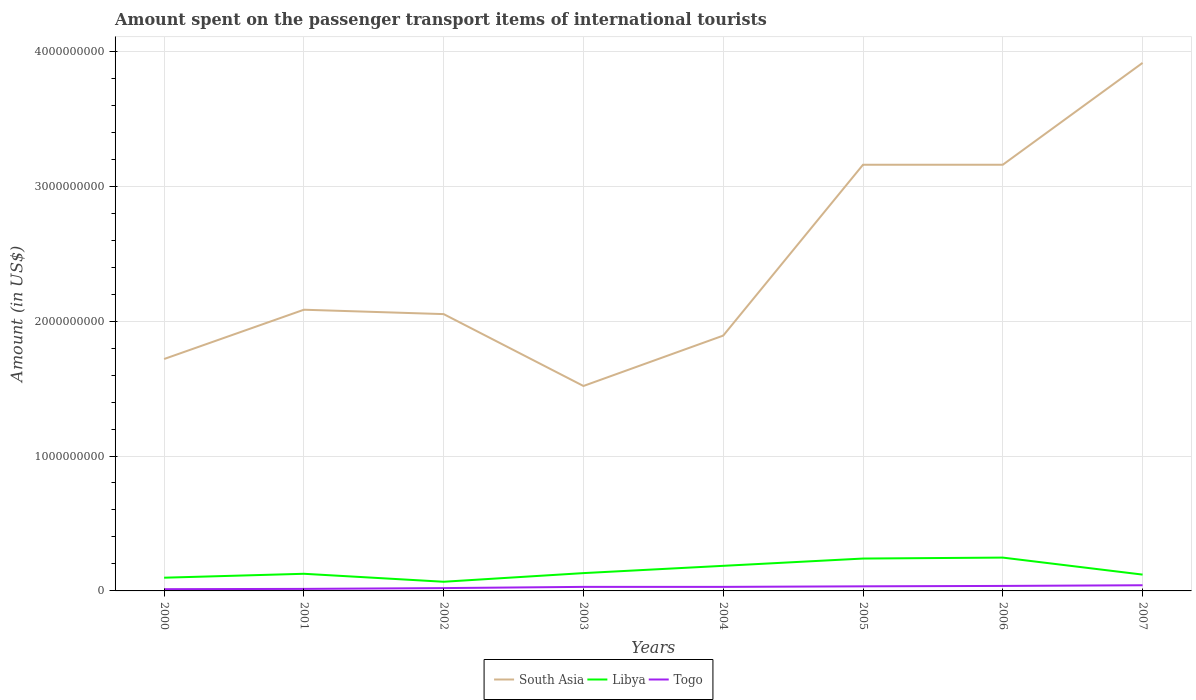Across all years, what is the maximum amount spent on the passenger transport items of international tourists in Togo?
Your response must be concise. 1.30e+07. In which year was the amount spent on the passenger transport items of international tourists in Togo maximum?
Offer a terse response. 2000. What is the total amount spent on the passenger transport items of international tourists in South Asia in the graph?
Make the answer very short. -1.07e+09. What is the difference between the highest and the second highest amount spent on the passenger transport items of international tourists in Togo?
Provide a short and direct response. 2.90e+07. Is the amount spent on the passenger transport items of international tourists in South Asia strictly greater than the amount spent on the passenger transport items of international tourists in Libya over the years?
Offer a very short reply. No. Are the values on the major ticks of Y-axis written in scientific E-notation?
Your answer should be very brief. No. Does the graph contain any zero values?
Keep it short and to the point. No. Where does the legend appear in the graph?
Your answer should be compact. Bottom center. What is the title of the graph?
Keep it short and to the point. Amount spent on the passenger transport items of international tourists. Does "Kenya" appear as one of the legend labels in the graph?
Make the answer very short. No. What is the Amount (in US$) in South Asia in 2000?
Your response must be concise. 1.72e+09. What is the Amount (in US$) of Libya in 2000?
Your answer should be very brief. 9.80e+07. What is the Amount (in US$) of Togo in 2000?
Provide a short and direct response. 1.30e+07. What is the Amount (in US$) of South Asia in 2001?
Offer a terse response. 2.08e+09. What is the Amount (in US$) of Libya in 2001?
Offer a very short reply. 1.27e+08. What is the Amount (in US$) in Togo in 2001?
Give a very brief answer. 1.50e+07. What is the Amount (in US$) of South Asia in 2002?
Your response must be concise. 2.05e+09. What is the Amount (in US$) in Libya in 2002?
Offer a very short reply. 6.80e+07. What is the Amount (in US$) in Togo in 2002?
Give a very brief answer. 2.10e+07. What is the Amount (in US$) of South Asia in 2003?
Your answer should be very brief. 1.52e+09. What is the Amount (in US$) of Libya in 2003?
Provide a succinct answer. 1.32e+08. What is the Amount (in US$) of Togo in 2003?
Provide a short and direct response. 3.00e+07. What is the Amount (in US$) of South Asia in 2004?
Make the answer very short. 1.89e+09. What is the Amount (in US$) in Libya in 2004?
Give a very brief answer. 1.86e+08. What is the Amount (in US$) of Togo in 2004?
Give a very brief answer. 3.00e+07. What is the Amount (in US$) in South Asia in 2005?
Offer a terse response. 3.16e+09. What is the Amount (in US$) in Libya in 2005?
Your response must be concise. 2.40e+08. What is the Amount (in US$) of Togo in 2005?
Make the answer very short. 3.40e+07. What is the Amount (in US$) in South Asia in 2006?
Your response must be concise. 3.16e+09. What is the Amount (in US$) of Libya in 2006?
Give a very brief answer. 2.47e+08. What is the Amount (in US$) in Togo in 2006?
Give a very brief answer. 3.70e+07. What is the Amount (in US$) of South Asia in 2007?
Give a very brief answer. 3.91e+09. What is the Amount (in US$) in Libya in 2007?
Keep it short and to the point. 1.21e+08. What is the Amount (in US$) of Togo in 2007?
Ensure brevity in your answer.  4.20e+07. Across all years, what is the maximum Amount (in US$) of South Asia?
Offer a terse response. 3.91e+09. Across all years, what is the maximum Amount (in US$) in Libya?
Offer a very short reply. 2.47e+08. Across all years, what is the maximum Amount (in US$) in Togo?
Your response must be concise. 4.20e+07. Across all years, what is the minimum Amount (in US$) of South Asia?
Your answer should be compact. 1.52e+09. Across all years, what is the minimum Amount (in US$) of Libya?
Ensure brevity in your answer.  6.80e+07. Across all years, what is the minimum Amount (in US$) of Togo?
Offer a terse response. 1.30e+07. What is the total Amount (in US$) of South Asia in the graph?
Ensure brevity in your answer.  1.95e+1. What is the total Amount (in US$) in Libya in the graph?
Provide a short and direct response. 1.22e+09. What is the total Amount (in US$) in Togo in the graph?
Keep it short and to the point. 2.22e+08. What is the difference between the Amount (in US$) of South Asia in 2000 and that in 2001?
Offer a terse response. -3.65e+08. What is the difference between the Amount (in US$) in Libya in 2000 and that in 2001?
Keep it short and to the point. -2.90e+07. What is the difference between the Amount (in US$) of South Asia in 2000 and that in 2002?
Give a very brief answer. -3.33e+08. What is the difference between the Amount (in US$) in Libya in 2000 and that in 2002?
Make the answer very short. 3.00e+07. What is the difference between the Amount (in US$) of Togo in 2000 and that in 2002?
Your response must be concise. -8.00e+06. What is the difference between the Amount (in US$) in South Asia in 2000 and that in 2003?
Provide a succinct answer. 2.00e+08. What is the difference between the Amount (in US$) of Libya in 2000 and that in 2003?
Offer a very short reply. -3.40e+07. What is the difference between the Amount (in US$) of Togo in 2000 and that in 2003?
Your answer should be compact. -1.70e+07. What is the difference between the Amount (in US$) of South Asia in 2000 and that in 2004?
Provide a succinct answer. -1.74e+08. What is the difference between the Amount (in US$) in Libya in 2000 and that in 2004?
Ensure brevity in your answer.  -8.80e+07. What is the difference between the Amount (in US$) in Togo in 2000 and that in 2004?
Keep it short and to the point. -1.70e+07. What is the difference between the Amount (in US$) of South Asia in 2000 and that in 2005?
Offer a terse response. -1.44e+09. What is the difference between the Amount (in US$) in Libya in 2000 and that in 2005?
Give a very brief answer. -1.42e+08. What is the difference between the Amount (in US$) of Togo in 2000 and that in 2005?
Keep it short and to the point. -2.10e+07. What is the difference between the Amount (in US$) of South Asia in 2000 and that in 2006?
Your answer should be compact. -1.44e+09. What is the difference between the Amount (in US$) of Libya in 2000 and that in 2006?
Provide a succinct answer. -1.49e+08. What is the difference between the Amount (in US$) in Togo in 2000 and that in 2006?
Give a very brief answer. -2.40e+07. What is the difference between the Amount (in US$) in South Asia in 2000 and that in 2007?
Your answer should be very brief. -2.19e+09. What is the difference between the Amount (in US$) in Libya in 2000 and that in 2007?
Keep it short and to the point. -2.30e+07. What is the difference between the Amount (in US$) in Togo in 2000 and that in 2007?
Your answer should be very brief. -2.90e+07. What is the difference between the Amount (in US$) of South Asia in 2001 and that in 2002?
Ensure brevity in your answer.  3.25e+07. What is the difference between the Amount (in US$) of Libya in 2001 and that in 2002?
Your answer should be very brief. 5.90e+07. What is the difference between the Amount (in US$) of Togo in 2001 and that in 2002?
Provide a succinct answer. -6.00e+06. What is the difference between the Amount (in US$) of South Asia in 2001 and that in 2003?
Keep it short and to the point. 5.65e+08. What is the difference between the Amount (in US$) of Libya in 2001 and that in 2003?
Ensure brevity in your answer.  -5.00e+06. What is the difference between the Amount (in US$) of Togo in 2001 and that in 2003?
Offer a very short reply. -1.50e+07. What is the difference between the Amount (in US$) in South Asia in 2001 and that in 2004?
Give a very brief answer. 1.92e+08. What is the difference between the Amount (in US$) in Libya in 2001 and that in 2004?
Offer a terse response. -5.90e+07. What is the difference between the Amount (in US$) in Togo in 2001 and that in 2004?
Ensure brevity in your answer.  -1.50e+07. What is the difference between the Amount (in US$) in South Asia in 2001 and that in 2005?
Offer a terse response. -1.07e+09. What is the difference between the Amount (in US$) of Libya in 2001 and that in 2005?
Offer a terse response. -1.13e+08. What is the difference between the Amount (in US$) in Togo in 2001 and that in 2005?
Provide a short and direct response. -1.90e+07. What is the difference between the Amount (in US$) of South Asia in 2001 and that in 2006?
Give a very brief answer. -1.07e+09. What is the difference between the Amount (in US$) of Libya in 2001 and that in 2006?
Provide a succinct answer. -1.20e+08. What is the difference between the Amount (in US$) of Togo in 2001 and that in 2006?
Provide a succinct answer. -2.20e+07. What is the difference between the Amount (in US$) of South Asia in 2001 and that in 2007?
Keep it short and to the point. -1.83e+09. What is the difference between the Amount (in US$) in Togo in 2001 and that in 2007?
Provide a short and direct response. -2.70e+07. What is the difference between the Amount (in US$) of South Asia in 2002 and that in 2003?
Make the answer very short. 5.33e+08. What is the difference between the Amount (in US$) in Libya in 2002 and that in 2003?
Your response must be concise. -6.40e+07. What is the difference between the Amount (in US$) of Togo in 2002 and that in 2003?
Keep it short and to the point. -9.00e+06. What is the difference between the Amount (in US$) of South Asia in 2002 and that in 2004?
Offer a very short reply. 1.59e+08. What is the difference between the Amount (in US$) in Libya in 2002 and that in 2004?
Provide a short and direct response. -1.18e+08. What is the difference between the Amount (in US$) in Togo in 2002 and that in 2004?
Your answer should be compact. -9.00e+06. What is the difference between the Amount (in US$) in South Asia in 2002 and that in 2005?
Keep it short and to the point. -1.11e+09. What is the difference between the Amount (in US$) in Libya in 2002 and that in 2005?
Offer a terse response. -1.72e+08. What is the difference between the Amount (in US$) in Togo in 2002 and that in 2005?
Keep it short and to the point. -1.30e+07. What is the difference between the Amount (in US$) of South Asia in 2002 and that in 2006?
Provide a succinct answer. -1.11e+09. What is the difference between the Amount (in US$) of Libya in 2002 and that in 2006?
Make the answer very short. -1.79e+08. What is the difference between the Amount (in US$) of Togo in 2002 and that in 2006?
Provide a succinct answer. -1.60e+07. What is the difference between the Amount (in US$) of South Asia in 2002 and that in 2007?
Offer a terse response. -1.86e+09. What is the difference between the Amount (in US$) of Libya in 2002 and that in 2007?
Offer a very short reply. -5.30e+07. What is the difference between the Amount (in US$) in Togo in 2002 and that in 2007?
Provide a succinct answer. -2.10e+07. What is the difference between the Amount (in US$) of South Asia in 2003 and that in 2004?
Your answer should be very brief. -3.73e+08. What is the difference between the Amount (in US$) of Libya in 2003 and that in 2004?
Give a very brief answer. -5.40e+07. What is the difference between the Amount (in US$) of Togo in 2003 and that in 2004?
Keep it short and to the point. 0. What is the difference between the Amount (in US$) of South Asia in 2003 and that in 2005?
Your answer should be compact. -1.64e+09. What is the difference between the Amount (in US$) of Libya in 2003 and that in 2005?
Your answer should be very brief. -1.08e+08. What is the difference between the Amount (in US$) of South Asia in 2003 and that in 2006?
Give a very brief answer. -1.64e+09. What is the difference between the Amount (in US$) of Libya in 2003 and that in 2006?
Provide a short and direct response. -1.15e+08. What is the difference between the Amount (in US$) in Togo in 2003 and that in 2006?
Your response must be concise. -7.00e+06. What is the difference between the Amount (in US$) in South Asia in 2003 and that in 2007?
Provide a short and direct response. -2.39e+09. What is the difference between the Amount (in US$) of Libya in 2003 and that in 2007?
Offer a terse response. 1.10e+07. What is the difference between the Amount (in US$) in Togo in 2003 and that in 2007?
Your answer should be compact. -1.20e+07. What is the difference between the Amount (in US$) in South Asia in 2004 and that in 2005?
Give a very brief answer. -1.27e+09. What is the difference between the Amount (in US$) in Libya in 2004 and that in 2005?
Your answer should be compact. -5.40e+07. What is the difference between the Amount (in US$) in Togo in 2004 and that in 2005?
Offer a very short reply. -4.00e+06. What is the difference between the Amount (in US$) of South Asia in 2004 and that in 2006?
Provide a succinct answer. -1.27e+09. What is the difference between the Amount (in US$) in Libya in 2004 and that in 2006?
Ensure brevity in your answer.  -6.10e+07. What is the difference between the Amount (in US$) in Togo in 2004 and that in 2006?
Your answer should be very brief. -7.00e+06. What is the difference between the Amount (in US$) in South Asia in 2004 and that in 2007?
Give a very brief answer. -2.02e+09. What is the difference between the Amount (in US$) in Libya in 2004 and that in 2007?
Your response must be concise. 6.50e+07. What is the difference between the Amount (in US$) in Togo in 2004 and that in 2007?
Keep it short and to the point. -1.20e+07. What is the difference between the Amount (in US$) of Libya in 2005 and that in 2006?
Give a very brief answer. -7.00e+06. What is the difference between the Amount (in US$) in Togo in 2005 and that in 2006?
Make the answer very short. -3.00e+06. What is the difference between the Amount (in US$) in South Asia in 2005 and that in 2007?
Provide a short and direct response. -7.55e+08. What is the difference between the Amount (in US$) of Libya in 2005 and that in 2007?
Make the answer very short. 1.19e+08. What is the difference between the Amount (in US$) of Togo in 2005 and that in 2007?
Your answer should be very brief. -8.00e+06. What is the difference between the Amount (in US$) in South Asia in 2006 and that in 2007?
Your answer should be compact. -7.55e+08. What is the difference between the Amount (in US$) in Libya in 2006 and that in 2007?
Your answer should be very brief. 1.26e+08. What is the difference between the Amount (in US$) of Togo in 2006 and that in 2007?
Make the answer very short. -5.00e+06. What is the difference between the Amount (in US$) in South Asia in 2000 and the Amount (in US$) in Libya in 2001?
Provide a succinct answer. 1.59e+09. What is the difference between the Amount (in US$) of South Asia in 2000 and the Amount (in US$) of Togo in 2001?
Provide a short and direct response. 1.70e+09. What is the difference between the Amount (in US$) in Libya in 2000 and the Amount (in US$) in Togo in 2001?
Make the answer very short. 8.30e+07. What is the difference between the Amount (in US$) of South Asia in 2000 and the Amount (in US$) of Libya in 2002?
Your answer should be compact. 1.65e+09. What is the difference between the Amount (in US$) of South Asia in 2000 and the Amount (in US$) of Togo in 2002?
Provide a short and direct response. 1.70e+09. What is the difference between the Amount (in US$) in Libya in 2000 and the Amount (in US$) in Togo in 2002?
Provide a short and direct response. 7.70e+07. What is the difference between the Amount (in US$) in South Asia in 2000 and the Amount (in US$) in Libya in 2003?
Offer a terse response. 1.59e+09. What is the difference between the Amount (in US$) in South Asia in 2000 and the Amount (in US$) in Togo in 2003?
Ensure brevity in your answer.  1.69e+09. What is the difference between the Amount (in US$) of Libya in 2000 and the Amount (in US$) of Togo in 2003?
Make the answer very short. 6.80e+07. What is the difference between the Amount (in US$) in South Asia in 2000 and the Amount (in US$) in Libya in 2004?
Make the answer very short. 1.53e+09. What is the difference between the Amount (in US$) in South Asia in 2000 and the Amount (in US$) in Togo in 2004?
Offer a very short reply. 1.69e+09. What is the difference between the Amount (in US$) in Libya in 2000 and the Amount (in US$) in Togo in 2004?
Give a very brief answer. 6.80e+07. What is the difference between the Amount (in US$) of South Asia in 2000 and the Amount (in US$) of Libya in 2005?
Your answer should be very brief. 1.48e+09. What is the difference between the Amount (in US$) of South Asia in 2000 and the Amount (in US$) of Togo in 2005?
Offer a terse response. 1.68e+09. What is the difference between the Amount (in US$) in Libya in 2000 and the Amount (in US$) in Togo in 2005?
Your response must be concise. 6.40e+07. What is the difference between the Amount (in US$) in South Asia in 2000 and the Amount (in US$) in Libya in 2006?
Make the answer very short. 1.47e+09. What is the difference between the Amount (in US$) in South Asia in 2000 and the Amount (in US$) in Togo in 2006?
Provide a succinct answer. 1.68e+09. What is the difference between the Amount (in US$) in Libya in 2000 and the Amount (in US$) in Togo in 2006?
Provide a succinct answer. 6.10e+07. What is the difference between the Amount (in US$) in South Asia in 2000 and the Amount (in US$) in Libya in 2007?
Give a very brief answer. 1.60e+09. What is the difference between the Amount (in US$) in South Asia in 2000 and the Amount (in US$) in Togo in 2007?
Your answer should be very brief. 1.68e+09. What is the difference between the Amount (in US$) in Libya in 2000 and the Amount (in US$) in Togo in 2007?
Your answer should be very brief. 5.60e+07. What is the difference between the Amount (in US$) in South Asia in 2001 and the Amount (in US$) in Libya in 2002?
Offer a terse response. 2.02e+09. What is the difference between the Amount (in US$) in South Asia in 2001 and the Amount (in US$) in Togo in 2002?
Keep it short and to the point. 2.06e+09. What is the difference between the Amount (in US$) of Libya in 2001 and the Amount (in US$) of Togo in 2002?
Your answer should be compact. 1.06e+08. What is the difference between the Amount (in US$) of South Asia in 2001 and the Amount (in US$) of Libya in 2003?
Ensure brevity in your answer.  1.95e+09. What is the difference between the Amount (in US$) in South Asia in 2001 and the Amount (in US$) in Togo in 2003?
Make the answer very short. 2.05e+09. What is the difference between the Amount (in US$) of Libya in 2001 and the Amount (in US$) of Togo in 2003?
Provide a short and direct response. 9.70e+07. What is the difference between the Amount (in US$) of South Asia in 2001 and the Amount (in US$) of Libya in 2004?
Your response must be concise. 1.90e+09. What is the difference between the Amount (in US$) of South Asia in 2001 and the Amount (in US$) of Togo in 2004?
Give a very brief answer. 2.05e+09. What is the difference between the Amount (in US$) of Libya in 2001 and the Amount (in US$) of Togo in 2004?
Provide a short and direct response. 9.70e+07. What is the difference between the Amount (in US$) in South Asia in 2001 and the Amount (in US$) in Libya in 2005?
Your response must be concise. 1.84e+09. What is the difference between the Amount (in US$) in South Asia in 2001 and the Amount (in US$) in Togo in 2005?
Offer a terse response. 2.05e+09. What is the difference between the Amount (in US$) of Libya in 2001 and the Amount (in US$) of Togo in 2005?
Ensure brevity in your answer.  9.30e+07. What is the difference between the Amount (in US$) in South Asia in 2001 and the Amount (in US$) in Libya in 2006?
Give a very brief answer. 1.84e+09. What is the difference between the Amount (in US$) of South Asia in 2001 and the Amount (in US$) of Togo in 2006?
Offer a very short reply. 2.05e+09. What is the difference between the Amount (in US$) in Libya in 2001 and the Amount (in US$) in Togo in 2006?
Ensure brevity in your answer.  9.00e+07. What is the difference between the Amount (in US$) of South Asia in 2001 and the Amount (in US$) of Libya in 2007?
Your response must be concise. 1.96e+09. What is the difference between the Amount (in US$) of South Asia in 2001 and the Amount (in US$) of Togo in 2007?
Your answer should be compact. 2.04e+09. What is the difference between the Amount (in US$) in Libya in 2001 and the Amount (in US$) in Togo in 2007?
Offer a very short reply. 8.50e+07. What is the difference between the Amount (in US$) of South Asia in 2002 and the Amount (in US$) of Libya in 2003?
Your answer should be very brief. 1.92e+09. What is the difference between the Amount (in US$) of South Asia in 2002 and the Amount (in US$) of Togo in 2003?
Keep it short and to the point. 2.02e+09. What is the difference between the Amount (in US$) in Libya in 2002 and the Amount (in US$) in Togo in 2003?
Make the answer very short. 3.80e+07. What is the difference between the Amount (in US$) of South Asia in 2002 and the Amount (in US$) of Libya in 2004?
Provide a short and direct response. 1.87e+09. What is the difference between the Amount (in US$) of South Asia in 2002 and the Amount (in US$) of Togo in 2004?
Your answer should be compact. 2.02e+09. What is the difference between the Amount (in US$) in Libya in 2002 and the Amount (in US$) in Togo in 2004?
Your response must be concise. 3.80e+07. What is the difference between the Amount (in US$) of South Asia in 2002 and the Amount (in US$) of Libya in 2005?
Offer a terse response. 1.81e+09. What is the difference between the Amount (in US$) in South Asia in 2002 and the Amount (in US$) in Togo in 2005?
Your answer should be compact. 2.02e+09. What is the difference between the Amount (in US$) of Libya in 2002 and the Amount (in US$) of Togo in 2005?
Your answer should be compact. 3.40e+07. What is the difference between the Amount (in US$) in South Asia in 2002 and the Amount (in US$) in Libya in 2006?
Your answer should be compact. 1.80e+09. What is the difference between the Amount (in US$) of South Asia in 2002 and the Amount (in US$) of Togo in 2006?
Your answer should be very brief. 2.01e+09. What is the difference between the Amount (in US$) of Libya in 2002 and the Amount (in US$) of Togo in 2006?
Offer a very short reply. 3.10e+07. What is the difference between the Amount (in US$) in South Asia in 2002 and the Amount (in US$) in Libya in 2007?
Offer a terse response. 1.93e+09. What is the difference between the Amount (in US$) in South Asia in 2002 and the Amount (in US$) in Togo in 2007?
Your answer should be very brief. 2.01e+09. What is the difference between the Amount (in US$) of Libya in 2002 and the Amount (in US$) of Togo in 2007?
Provide a short and direct response. 2.60e+07. What is the difference between the Amount (in US$) in South Asia in 2003 and the Amount (in US$) in Libya in 2004?
Your answer should be very brief. 1.33e+09. What is the difference between the Amount (in US$) of South Asia in 2003 and the Amount (in US$) of Togo in 2004?
Give a very brief answer. 1.49e+09. What is the difference between the Amount (in US$) in Libya in 2003 and the Amount (in US$) in Togo in 2004?
Ensure brevity in your answer.  1.02e+08. What is the difference between the Amount (in US$) of South Asia in 2003 and the Amount (in US$) of Libya in 2005?
Your answer should be compact. 1.28e+09. What is the difference between the Amount (in US$) in South Asia in 2003 and the Amount (in US$) in Togo in 2005?
Keep it short and to the point. 1.49e+09. What is the difference between the Amount (in US$) of Libya in 2003 and the Amount (in US$) of Togo in 2005?
Offer a very short reply. 9.80e+07. What is the difference between the Amount (in US$) of South Asia in 2003 and the Amount (in US$) of Libya in 2006?
Your answer should be compact. 1.27e+09. What is the difference between the Amount (in US$) in South Asia in 2003 and the Amount (in US$) in Togo in 2006?
Offer a terse response. 1.48e+09. What is the difference between the Amount (in US$) in Libya in 2003 and the Amount (in US$) in Togo in 2006?
Provide a short and direct response. 9.50e+07. What is the difference between the Amount (in US$) of South Asia in 2003 and the Amount (in US$) of Libya in 2007?
Your response must be concise. 1.40e+09. What is the difference between the Amount (in US$) of South Asia in 2003 and the Amount (in US$) of Togo in 2007?
Provide a succinct answer. 1.48e+09. What is the difference between the Amount (in US$) of Libya in 2003 and the Amount (in US$) of Togo in 2007?
Your answer should be compact. 9.00e+07. What is the difference between the Amount (in US$) in South Asia in 2004 and the Amount (in US$) in Libya in 2005?
Make the answer very short. 1.65e+09. What is the difference between the Amount (in US$) in South Asia in 2004 and the Amount (in US$) in Togo in 2005?
Offer a terse response. 1.86e+09. What is the difference between the Amount (in US$) in Libya in 2004 and the Amount (in US$) in Togo in 2005?
Offer a very short reply. 1.52e+08. What is the difference between the Amount (in US$) in South Asia in 2004 and the Amount (in US$) in Libya in 2006?
Make the answer very short. 1.65e+09. What is the difference between the Amount (in US$) of South Asia in 2004 and the Amount (in US$) of Togo in 2006?
Provide a short and direct response. 1.86e+09. What is the difference between the Amount (in US$) of Libya in 2004 and the Amount (in US$) of Togo in 2006?
Keep it short and to the point. 1.49e+08. What is the difference between the Amount (in US$) in South Asia in 2004 and the Amount (in US$) in Libya in 2007?
Provide a succinct answer. 1.77e+09. What is the difference between the Amount (in US$) of South Asia in 2004 and the Amount (in US$) of Togo in 2007?
Your answer should be very brief. 1.85e+09. What is the difference between the Amount (in US$) of Libya in 2004 and the Amount (in US$) of Togo in 2007?
Offer a terse response. 1.44e+08. What is the difference between the Amount (in US$) in South Asia in 2005 and the Amount (in US$) in Libya in 2006?
Your response must be concise. 2.91e+09. What is the difference between the Amount (in US$) in South Asia in 2005 and the Amount (in US$) in Togo in 2006?
Provide a succinct answer. 3.12e+09. What is the difference between the Amount (in US$) of Libya in 2005 and the Amount (in US$) of Togo in 2006?
Offer a terse response. 2.03e+08. What is the difference between the Amount (in US$) in South Asia in 2005 and the Amount (in US$) in Libya in 2007?
Offer a very short reply. 3.04e+09. What is the difference between the Amount (in US$) of South Asia in 2005 and the Amount (in US$) of Togo in 2007?
Provide a succinct answer. 3.12e+09. What is the difference between the Amount (in US$) in Libya in 2005 and the Amount (in US$) in Togo in 2007?
Give a very brief answer. 1.98e+08. What is the difference between the Amount (in US$) of South Asia in 2006 and the Amount (in US$) of Libya in 2007?
Make the answer very short. 3.04e+09. What is the difference between the Amount (in US$) of South Asia in 2006 and the Amount (in US$) of Togo in 2007?
Ensure brevity in your answer.  3.12e+09. What is the difference between the Amount (in US$) in Libya in 2006 and the Amount (in US$) in Togo in 2007?
Your answer should be compact. 2.05e+08. What is the average Amount (in US$) of South Asia per year?
Your answer should be very brief. 2.44e+09. What is the average Amount (in US$) in Libya per year?
Make the answer very short. 1.52e+08. What is the average Amount (in US$) of Togo per year?
Keep it short and to the point. 2.78e+07. In the year 2000, what is the difference between the Amount (in US$) in South Asia and Amount (in US$) in Libya?
Make the answer very short. 1.62e+09. In the year 2000, what is the difference between the Amount (in US$) in South Asia and Amount (in US$) in Togo?
Keep it short and to the point. 1.71e+09. In the year 2000, what is the difference between the Amount (in US$) in Libya and Amount (in US$) in Togo?
Give a very brief answer. 8.50e+07. In the year 2001, what is the difference between the Amount (in US$) in South Asia and Amount (in US$) in Libya?
Make the answer very short. 1.96e+09. In the year 2001, what is the difference between the Amount (in US$) of South Asia and Amount (in US$) of Togo?
Your answer should be compact. 2.07e+09. In the year 2001, what is the difference between the Amount (in US$) of Libya and Amount (in US$) of Togo?
Give a very brief answer. 1.12e+08. In the year 2002, what is the difference between the Amount (in US$) of South Asia and Amount (in US$) of Libya?
Offer a very short reply. 1.98e+09. In the year 2002, what is the difference between the Amount (in US$) of South Asia and Amount (in US$) of Togo?
Make the answer very short. 2.03e+09. In the year 2002, what is the difference between the Amount (in US$) in Libya and Amount (in US$) in Togo?
Offer a very short reply. 4.70e+07. In the year 2003, what is the difference between the Amount (in US$) in South Asia and Amount (in US$) in Libya?
Your answer should be very brief. 1.39e+09. In the year 2003, what is the difference between the Amount (in US$) in South Asia and Amount (in US$) in Togo?
Offer a terse response. 1.49e+09. In the year 2003, what is the difference between the Amount (in US$) in Libya and Amount (in US$) in Togo?
Ensure brevity in your answer.  1.02e+08. In the year 2004, what is the difference between the Amount (in US$) in South Asia and Amount (in US$) in Libya?
Give a very brief answer. 1.71e+09. In the year 2004, what is the difference between the Amount (in US$) in South Asia and Amount (in US$) in Togo?
Provide a succinct answer. 1.86e+09. In the year 2004, what is the difference between the Amount (in US$) of Libya and Amount (in US$) of Togo?
Offer a very short reply. 1.56e+08. In the year 2005, what is the difference between the Amount (in US$) in South Asia and Amount (in US$) in Libya?
Your answer should be compact. 2.92e+09. In the year 2005, what is the difference between the Amount (in US$) of South Asia and Amount (in US$) of Togo?
Provide a short and direct response. 3.12e+09. In the year 2005, what is the difference between the Amount (in US$) in Libya and Amount (in US$) in Togo?
Your answer should be very brief. 2.06e+08. In the year 2006, what is the difference between the Amount (in US$) of South Asia and Amount (in US$) of Libya?
Ensure brevity in your answer.  2.91e+09. In the year 2006, what is the difference between the Amount (in US$) in South Asia and Amount (in US$) in Togo?
Offer a terse response. 3.12e+09. In the year 2006, what is the difference between the Amount (in US$) in Libya and Amount (in US$) in Togo?
Make the answer very short. 2.10e+08. In the year 2007, what is the difference between the Amount (in US$) in South Asia and Amount (in US$) in Libya?
Offer a very short reply. 3.79e+09. In the year 2007, what is the difference between the Amount (in US$) of South Asia and Amount (in US$) of Togo?
Provide a succinct answer. 3.87e+09. In the year 2007, what is the difference between the Amount (in US$) of Libya and Amount (in US$) of Togo?
Your answer should be very brief. 7.90e+07. What is the ratio of the Amount (in US$) in South Asia in 2000 to that in 2001?
Keep it short and to the point. 0.82. What is the ratio of the Amount (in US$) of Libya in 2000 to that in 2001?
Your answer should be very brief. 0.77. What is the ratio of the Amount (in US$) of Togo in 2000 to that in 2001?
Offer a terse response. 0.87. What is the ratio of the Amount (in US$) of South Asia in 2000 to that in 2002?
Make the answer very short. 0.84. What is the ratio of the Amount (in US$) in Libya in 2000 to that in 2002?
Your response must be concise. 1.44. What is the ratio of the Amount (in US$) in Togo in 2000 to that in 2002?
Your response must be concise. 0.62. What is the ratio of the Amount (in US$) of South Asia in 2000 to that in 2003?
Keep it short and to the point. 1.13. What is the ratio of the Amount (in US$) of Libya in 2000 to that in 2003?
Offer a very short reply. 0.74. What is the ratio of the Amount (in US$) of Togo in 2000 to that in 2003?
Provide a succinct answer. 0.43. What is the ratio of the Amount (in US$) of South Asia in 2000 to that in 2004?
Ensure brevity in your answer.  0.91. What is the ratio of the Amount (in US$) in Libya in 2000 to that in 2004?
Give a very brief answer. 0.53. What is the ratio of the Amount (in US$) of Togo in 2000 to that in 2004?
Offer a very short reply. 0.43. What is the ratio of the Amount (in US$) of South Asia in 2000 to that in 2005?
Ensure brevity in your answer.  0.54. What is the ratio of the Amount (in US$) in Libya in 2000 to that in 2005?
Your answer should be very brief. 0.41. What is the ratio of the Amount (in US$) of Togo in 2000 to that in 2005?
Provide a succinct answer. 0.38. What is the ratio of the Amount (in US$) in South Asia in 2000 to that in 2006?
Your answer should be very brief. 0.54. What is the ratio of the Amount (in US$) of Libya in 2000 to that in 2006?
Your answer should be very brief. 0.4. What is the ratio of the Amount (in US$) of Togo in 2000 to that in 2006?
Your answer should be compact. 0.35. What is the ratio of the Amount (in US$) in South Asia in 2000 to that in 2007?
Offer a terse response. 0.44. What is the ratio of the Amount (in US$) in Libya in 2000 to that in 2007?
Keep it short and to the point. 0.81. What is the ratio of the Amount (in US$) in Togo in 2000 to that in 2007?
Make the answer very short. 0.31. What is the ratio of the Amount (in US$) of South Asia in 2001 to that in 2002?
Make the answer very short. 1.02. What is the ratio of the Amount (in US$) of Libya in 2001 to that in 2002?
Ensure brevity in your answer.  1.87. What is the ratio of the Amount (in US$) of South Asia in 2001 to that in 2003?
Your answer should be very brief. 1.37. What is the ratio of the Amount (in US$) of Libya in 2001 to that in 2003?
Offer a very short reply. 0.96. What is the ratio of the Amount (in US$) in South Asia in 2001 to that in 2004?
Make the answer very short. 1.1. What is the ratio of the Amount (in US$) of Libya in 2001 to that in 2004?
Keep it short and to the point. 0.68. What is the ratio of the Amount (in US$) in Togo in 2001 to that in 2004?
Make the answer very short. 0.5. What is the ratio of the Amount (in US$) of South Asia in 2001 to that in 2005?
Keep it short and to the point. 0.66. What is the ratio of the Amount (in US$) of Libya in 2001 to that in 2005?
Ensure brevity in your answer.  0.53. What is the ratio of the Amount (in US$) in Togo in 2001 to that in 2005?
Provide a succinct answer. 0.44. What is the ratio of the Amount (in US$) in South Asia in 2001 to that in 2006?
Make the answer very short. 0.66. What is the ratio of the Amount (in US$) in Libya in 2001 to that in 2006?
Provide a succinct answer. 0.51. What is the ratio of the Amount (in US$) of Togo in 2001 to that in 2006?
Your answer should be compact. 0.41. What is the ratio of the Amount (in US$) of South Asia in 2001 to that in 2007?
Give a very brief answer. 0.53. What is the ratio of the Amount (in US$) of Libya in 2001 to that in 2007?
Ensure brevity in your answer.  1.05. What is the ratio of the Amount (in US$) of Togo in 2001 to that in 2007?
Offer a terse response. 0.36. What is the ratio of the Amount (in US$) in South Asia in 2002 to that in 2003?
Your answer should be very brief. 1.35. What is the ratio of the Amount (in US$) of Libya in 2002 to that in 2003?
Keep it short and to the point. 0.52. What is the ratio of the Amount (in US$) in South Asia in 2002 to that in 2004?
Provide a succinct answer. 1.08. What is the ratio of the Amount (in US$) of Libya in 2002 to that in 2004?
Offer a very short reply. 0.37. What is the ratio of the Amount (in US$) of Togo in 2002 to that in 2004?
Your answer should be compact. 0.7. What is the ratio of the Amount (in US$) of South Asia in 2002 to that in 2005?
Make the answer very short. 0.65. What is the ratio of the Amount (in US$) of Libya in 2002 to that in 2005?
Keep it short and to the point. 0.28. What is the ratio of the Amount (in US$) of Togo in 2002 to that in 2005?
Your answer should be very brief. 0.62. What is the ratio of the Amount (in US$) of South Asia in 2002 to that in 2006?
Your answer should be compact. 0.65. What is the ratio of the Amount (in US$) of Libya in 2002 to that in 2006?
Your response must be concise. 0.28. What is the ratio of the Amount (in US$) of Togo in 2002 to that in 2006?
Offer a very short reply. 0.57. What is the ratio of the Amount (in US$) in South Asia in 2002 to that in 2007?
Provide a short and direct response. 0.52. What is the ratio of the Amount (in US$) of Libya in 2002 to that in 2007?
Make the answer very short. 0.56. What is the ratio of the Amount (in US$) of South Asia in 2003 to that in 2004?
Offer a terse response. 0.8. What is the ratio of the Amount (in US$) in Libya in 2003 to that in 2004?
Offer a terse response. 0.71. What is the ratio of the Amount (in US$) in Togo in 2003 to that in 2004?
Provide a succinct answer. 1. What is the ratio of the Amount (in US$) of South Asia in 2003 to that in 2005?
Offer a terse response. 0.48. What is the ratio of the Amount (in US$) in Libya in 2003 to that in 2005?
Provide a succinct answer. 0.55. What is the ratio of the Amount (in US$) of Togo in 2003 to that in 2005?
Offer a terse response. 0.88. What is the ratio of the Amount (in US$) of South Asia in 2003 to that in 2006?
Offer a very short reply. 0.48. What is the ratio of the Amount (in US$) in Libya in 2003 to that in 2006?
Your answer should be compact. 0.53. What is the ratio of the Amount (in US$) in Togo in 2003 to that in 2006?
Offer a terse response. 0.81. What is the ratio of the Amount (in US$) of South Asia in 2003 to that in 2007?
Ensure brevity in your answer.  0.39. What is the ratio of the Amount (in US$) of Libya in 2003 to that in 2007?
Your answer should be very brief. 1.09. What is the ratio of the Amount (in US$) in Togo in 2003 to that in 2007?
Provide a succinct answer. 0.71. What is the ratio of the Amount (in US$) of South Asia in 2004 to that in 2005?
Ensure brevity in your answer.  0.6. What is the ratio of the Amount (in US$) in Libya in 2004 to that in 2005?
Provide a succinct answer. 0.78. What is the ratio of the Amount (in US$) in Togo in 2004 to that in 2005?
Make the answer very short. 0.88. What is the ratio of the Amount (in US$) in South Asia in 2004 to that in 2006?
Make the answer very short. 0.6. What is the ratio of the Amount (in US$) of Libya in 2004 to that in 2006?
Give a very brief answer. 0.75. What is the ratio of the Amount (in US$) of Togo in 2004 to that in 2006?
Keep it short and to the point. 0.81. What is the ratio of the Amount (in US$) of South Asia in 2004 to that in 2007?
Ensure brevity in your answer.  0.48. What is the ratio of the Amount (in US$) in Libya in 2004 to that in 2007?
Your response must be concise. 1.54. What is the ratio of the Amount (in US$) in Togo in 2004 to that in 2007?
Offer a terse response. 0.71. What is the ratio of the Amount (in US$) of South Asia in 2005 to that in 2006?
Offer a terse response. 1. What is the ratio of the Amount (in US$) of Libya in 2005 to that in 2006?
Ensure brevity in your answer.  0.97. What is the ratio of the Amount (in US$) of Togo in 2005 to that in 2006?
Offer a very short reply. 0.92. What is the ratio of the Amount (in US$) in South Asia in 2005 to that in 2007?
Offer a terse response. 0.81. What is the ratio of the Amount (in US$) of Libya in 2005 to that in 2007?
Give a very brief answer. 1.98. What is the ratio of the Amount (in US$) of Togo in 2005 to that in 2007?
Make the answer very short. 0.81. What is the ratio of the Amount (in US$) in South Asia in 2006 to that in 2007?
Ensure brevity in your answer.  0.81. What is the ratio of the Amount (in US$) in Libya in 2006 to that in 2007?
Offer a very short reply. 2.04. What is the ratio of the Amount (in US$) in Togo in 2006 to that in 2007?
Your answer should be very brief. 0.88. What is the difference between the highest and the second highest Amount (in US$) of South Asia?
Make the answer very short. 7.55e+08. What is the difference between the highest and the second highest Amount (in US$) in Libya?
Provide a succinct answer. 7.00e+06. What is the difference between the highest and the second highest Amount (in US$) in Togo?
Your answer should be compact. 5.00e+06. What is the difference between the highest and the lowest Amount (in US$) of South Asia?
Offer a very short reply. 2.39e+09. What is the difference between the highest and the lowest Amount (in US$) in Libya?
Your response must be concise. 1.79e+08. What is the difference between the highest and the lowest Amount (in US$) in Togo?
Make the answer very short. 2.90e+07. 